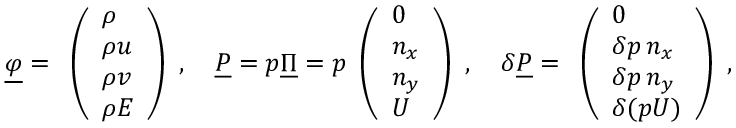Convert formula to latex. <formula><loc_0><loc_0><loc_500><loc_500>\underline { \varphi } = \begin{array} { l } { \left ( \begin{array} { l } { \rho } \\ { \rho u } \\ { \rho v } \\ { \rho E } \end{array} \right ) } \end{array} , \quad \underline { P } = p \underline { \Pi } = p \begin{array} { l } { \left ( \begin{array} { l } { 0 } \\ { n _ { x } } \\ { n _ { y } } \\ { U } \end{array} \right ) } \end{array} , \quad \delta \underline { P } = \begin{array} { l } { \left ( \begin{array} { l } { 0 } \\ { \delta p \, n _ { x } } \\ { \delta p \, n _ { y } } \\ { \delta ( p U ) } \end{array} \right ) } \end{array} ,</formula> 